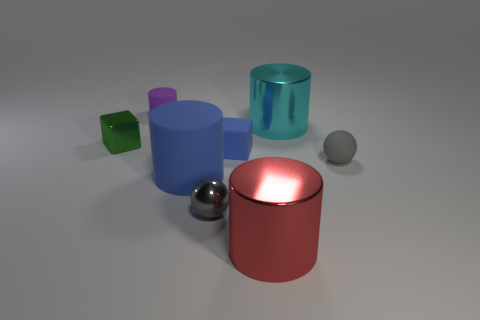What shape is the tiny rubber thing that is the same color as the tiny metal ball?
Make the answer very short. Sphere. What is the gray sphere that is right of the small sphere that is on the left side of the tiny block that is to the right of the green block made of?
Provide a succinct answer. Rubber. What is the shape of the small gray thing that is made of the same material as the tiny blue thing?
Make the answer very short. Sphere. Are there any other things that have the same color as the metal cube?
Offer a very short reply. No. There is a shiny cylinder that is in front of the small gray sphere that is to the right of the cyan object; how many purple objects are behind it?
Your answer should be very brief. 1. How many yellow objects are small metal balls or tiny spheres?
Give a very brief answer. 0. Does the red metal object have the same size as the blue thing that is in front of the blue block?
Ensure brevity in your answer.  Yes. There is another big cyan object that is the same shape as the big matte object; what is its material?
Keep it short and to the point. Metal. How many other objects are there of the same size as the green thing?
Your answer should be compact. 4. What is the shape of the big thing on the left side of the tiny gray ball in front of the small gray sphere that is right of the gray metal thing?
Offer a terse response. Cylinder. 